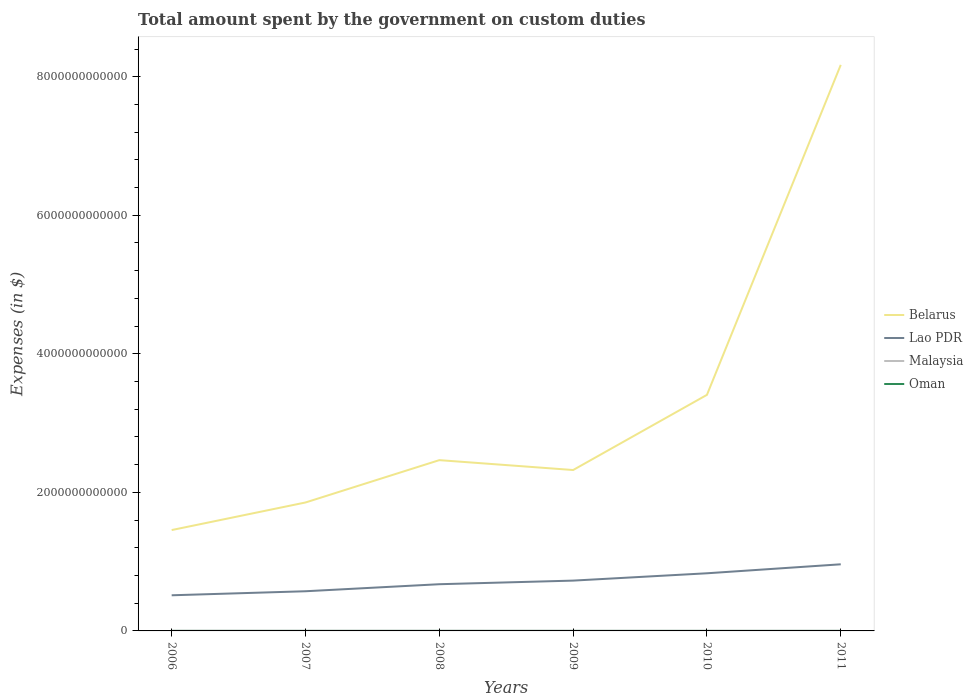How many different coloured lines are there?
Keep it short and to the point. 4. Is the number of lines equal to the number of legend labels?
Your response must be concise. Yes. Across all years, what is the maximum amount spent on custom duties by the government in Belarus?
Your answer should be very brief. 1.46e+12. In which year was the amount spent on custom duties by the government in Belarus maximum?
Make the answer very short. 2006. What is the total amount spent on custom duties by the government in Belarus in the graph?
Provide a succinct answer. -6.11e+11. What is the difference between the highest and the second highest amount spent on custom duties by the government in Malaysia?
Provide a short and direct response. 7.12e+08. Is the amount spent on custom duties by the government in Oman strictly greater than the amount spent on custom duties by the government in Belarus over the years?
Your response must be concise. Yes. How many lines are there?
Your answer should be compact. 4. What is the difference between two consecutive major ticks on the Y-axis?
Offer a very short reply. 2.00e+12. Are the values on the major ticks of Y-axis written in scientific E-notation?
Your response must be concise. No. Does the graph contain any zero values?
Offer a very short reply. No. Where does the legend appear in the graph?
Provide a succinct answer. Center right. What is the title of the graph?
Your response must be concise. Total amount spent by the government on custom duties. What is the label or title of the X-axis?
Your response must be concise. Years. What is the label or title of the Y-axis?
Keep it short and to the point. Expenses (in $). What is the Expenses (in $) in Belarus in 2006?
Give a very brief answer. 1.46e+12. What is the Expenses (in $) in Lao PDR in 2006?
Offer a terse response. 5.15e+11. What is the Expenses (in $) of Malaysia in 2006?
Provide a short and direct response. 2.68e+09. What is the Expenses (in $) of Oman in 2006?
Provide a succinct answer. 1.15e+08. What is the Expenses (in $) in Belarus in 2007?
Your answer should be compact. 1.85e+12. What is the Expenses (in $) of Lao PDR in 2007?
Offer a terse response. 5.73e+11. What is the Expenses (in $) of Malaysia in 2007?
Ensure brevity in your answer.  2.42e+09. What is the Expenses (in $) of Oman in 2007?
Your answer should be very brief. 1.60e+08. What is the Expenses (in $) of Belarus in 2008?
Provide a short and direct response. 2.47e+12. What is the Expenses (in $) in Lao PDR in 2008?
Give a very brief answer. 6.74e+11. What is the Expenses (in $) of Malaysia in 2008?
Your answer should be compact. 2.64e+09. What is the Expenses (in $) of Oman in 2008?
Make the answer very short. 2.27e+08. What is the Expenses (in $) of Belarus in 2009?
Provide a succinct answer. 2.32e+12. What is the Expenses (in $) in Lao PDR in 2009?
Your answer should be very brief. 7.26e+11. What is the Expenses (in $) in Malaysia in 2009?
Offer a terse response. 2.11e+09. What is the Expenses (in $) in Oman in 2009?
Ensure brevity in your answer.  1.58e+08. What is the Expenses (in $) of Belarus in 2010?
Offer a terse response. 3.41e+12. What is the Expenses (in $) in Lao PDR in 2010?
Provide a succinct answer. 8.32e+11. What is the Expenses (in $) of Malaysia in 2010?
Provide a short and direct response. 1.97e+09. What is the Expenses (in $) in Oman in 2010?
Keep it short and to the point. 1.80e+08. What is the Expenses (in $) of Belarus in 2011?
Your response must be concise. 8.17e+12. What is the Expenses (in $) in Lao PDR in 2011?
Make the answer very short. 9.62e+11. What is the Expenses (in $) in Malaysia in 2011?
Your answer should be very brief. 2.03e+09. What is the Expenses (in $) of Oman in 2011?
Offer a very short reply. 1.61e+08. Across all years, what is the maximum Expenses (in $) of Belarus?
Make the answer very short. 8.17e+12. Across all years, what is the maximum Expenses (in $) in Lao PDR?
Give a very brief answer. 9.62e+11. Across all years, what is the maximum Expenses (in $) of Malaysia?
Give a very brief answer. 2.68e+09. Across all years, what is the maximum Expenses (in $) of Oman?
Your answer should be compact. 2.27e+08. Across all years, what is the minimum Expenses (in $) of Belarus?
Offer a terse response. 1.46e+12. Across all years, what is the minimum Expenses (in $) in Lao PDR?
Keep it short and to the point. 5.15e+11. Across all years, what is the minimum Expenses (in $) in Malaysia?
Give a very brief answer. 1.97e+09. Across all years, what is the minimum Expenses (in $) of Oman?
Provide a succinct answer. 1.15e+08. What is the total Expenses (in $) in Belarus in the graph?
Your answer should be compact. 1.97e+13. What is the total Expenses (in $) of Lao PDR in the graph?
Your answer should be compact. 4.28e+12. What is the total Expenses (in $) of Malaysia in the graph?
Offer a very short reply. 1.38e+1. What is the total Expenses (in $) of Oman in the graph?
Keep it short and to the point. 1.00e+09. What is the difference between the Expenses (in $) in Belarus in 2006 and that in 2007?
Your answer should be compact. -3.98e+11. What is the difference between the Expenses (in $) in Lao PDR in 2006 and that in 2007?
Your response must be concise. -5.81e+1. What is the difference between the Expenses (in $) in Malaysia in 2006 and that in 2007?
Your answer should be very brief. 2.54e+08. What is the difference between the Expenses (in $) in Oman in 2006 and that in 2007?
Provide a succinct answer. -4.50e+07. What is the difference between the Expenses (in $) of Belarus in 2006 and that in 2008?
Offer a terse response. -1.01e+12. What is the difference between the Expenses (in $) of Lao PDR in 2006 and that in 2008?
Ensure brevity in your answer.  -1.60e+11. What is the difference between the Expenses (in $) in Malaysia in 2006 and that in 2008?
Your answer should be compact. 4.35e+07. What is the difference between the Expenses (in $) of Oman in 2006 and that in 2008?
Your answer should be very brief. -1.12e+08. What is the difference between the Expenses (in $) of Belarus in 2006 and that in 2009?
Your response must be concise. -8.67e+11. What is the difference between the Expenses (in $) in Lao PDR in 2006 and that in 2009?
Your answer should be very brief. -2.12e+11. What is the difference between the Expenses (in $) in Malaysia in 2006 and that in 2009?
Provide a short and direct response. 5.64e+08. What is the difference between the Expenses (in $) of Oman in 2006 and that in 2009?
Make the answer very short. -4.35e+07. What is the difference between the Expenses (in $) of Belarus in 2006 and that in 2010?
Keep it short and to the point. -1.95e+12. What is the difference between the Expenses (in $) in Lao PDR in 2006 and that in 2010?
Make the answer very short. -3.17e+11. What is the difference between the Expenses (in $) in Malaysia in 2006 and that in 2010?
Provide a short and direct response. 7.12e+08. What is the difference between the Expenses (in $) of Oman in 2006 and that in 2010?
Offer a terse response. -6.50e+07. What is the difference between the Expenses (in $) of Belarus in 2006 and that in 2011?
Offer a terse response. -6.72e+12. What is the difference between the Expenses (in $) in Lao PDR in 2006 and that in 2011?
Keep it short and to the point. -4.47e+11. What is the difference between the Expenses (in $) of Malaysia in 2006 and that in 2011?
Give a very brief answer. 6.53e+08. What is the difference between the Expenses (in $) in Oman in 2006 and that in 2011?
Keep it short and to the point. -4.66e+07. What is the difference between the Expenses (in $) of Belarus in 2007 and that in 2008?
Provide a short and direct response. -6.11e+11. What is the difference between the Expenses (in $) in Lao PDR in 2007 and that in 2008?
Your response must be concise. -1.02e+11. What is the difference between the Expenses (in $) in Malaysia in 2007 and that in 2008?
Offer a terse response. -2.11e+08. What is the difference between the Expenses (in $) in Oman in 2007 and that in 2008?
Your answer should be compact. -6.70e+07. What is the difference between the Expenses (in $) of Belarus in 2007 and that in 2009?
Ensure brevity in your answer.  -4.68e+11. What is the difference between the Expenses (in $) in Lao PDR in 2007 and that in 2009?
Provide a short and direct response. -1.54e+11. What is the difference between the Expenses (in $) in Malaysia in 2007 and that in 2009?
Give a very brief answer. 3.10e+08. What is the difference between the Expenses (in $) of Oman in 2007 and that in 2009?
Your answer should be very brief. 1.50e+06. What is the difference between the Expenses (in $) in Belarus in 2007 and that in 2010?
Keep it short and to the point. -1.55e+12. What is the difference between the Expenses (in $) in Lao PDR in 2007 and that in 2010?
Make the answer very short. -2.59e+11. What is the difference between the Expenses (in $) of Malaysia in 2007 and that in 2010?
Provide a short and direct response. 4.58e+08. What is the difference between the Expenses (in $) in Oman in 2007 and that in 2010?
Offer a terse response. -2.00e+07. What is the difference between the Expenses (in $) of Belarus in 2007 and that in 2011?
Keep it short and to the point. -6.32e+12. What is the difference between the Expenses (in $) of Lao PDR in 2007 and that in 2011?
Your answer should be compact. -3.89e+11. What is the difference between the Expenses (in $) in Malaysia in 2007 and that in 2011?
Provide a short and direct response. 3.98e+08. What is the difference between the Expenses (in $) in Oman in 2007 and that in 2011?
Provide a short and direct response. -1.60e+06. What is the difference between the Expenses (in $) in Belarus in 2008 and that in 2009?
Make the answer very short. 1.43e+11. What is the difference between the Expenses (in $) in Lao PDR in 2008 and that in 2009?
Your response must be concise. -5.20e+1. What is the difference between the Expenses (in $) of Malaysia in 2008 and that in 2009?
Make the answer very short. 5.21e+08. What is the difference between the Expenses (in $) of Oman in 2008 and that in 2009?
Your answer should be compact. 6.85e+07. What is the difference between the Expenses (in $) of Belarus in 2008 and that in 2010?
Offer a very short reply. -9.43e+11. What is the difference between the Expenses (in $) in Lao PDR in 2008 and that in 2010?
Your response must be concise. -1.58e+11. What is the difference between the Expenses (in $) of Malaysia in 2008 and that in 2010?
Your answer should be very brief. 6.69e+08. What is the difference between the Expenses (in $) in Oman in 2008 and that in 2010?
Your answer should be very brief. 4.70e+07. What is the difference between the Expenses (in $) of Belarus in 2008 and that in 2011?
Ensure brevity in your answer.  -5.71e+12. What is the difference between the Expenses (in $) in Lao PDR in 2008 and that in 2011?
Give a very brief answer. -2.88e+11. What is the difference between the Expenses (in $) in Malaysia in 2008 and that in 2011?
Ensure brevity in your answer.  6.09e+08. What is the difference between the Expenses (in $) of Oman in 2008 and that in 2011?
Make the answer very short. 6.54e+07. What is the difference between the Expenses (in $) of Belarus in 2009 and that in 2010?
Ensure brevity in your answer.  -1.09e+12. What is the difference between the Expenses (in $) in Lao PDR in 2009 and that in 2010?
Make the answer very short. -1.06e+11. What is the difference between the Expenses (in $) of Malaysia in 2009 and that in 2010?
Provide a short and direct response. 1.48e+08. What is the difference between the Expenses (in $) of Oman in 2009 and that in 2010?
Make the answer very short. -2.15e+07. What is the difference between the Expenses (in $) of Belarus in 2009 and that in 2011?
Provide a short and direct response. -5.85e+12. What is the difference between the Expenses (in $) in Lao PDR in 2009 and that in 2011?
Offer a terse response. -2.35e+11. What is the difference between the Expenses (in $) in Malaysia in 2009 and that in 2011?
Ensure brevity in your answer.  8.83e+07. What is the difference between the Expenses (in $) of Oman in 2009 and that in 2011?
Provide a succinct answer. -3.10e+06. What is the difference between the Expenses (in $) in Belarus in 2010 and that in 2011?
Provide a short and direct response. -4.76e+12. What is the difference between the Expenses (in $) of Lao PDR in 2010 and that in 2011?
Offer a terse response. -1.30e+11. What is the difference between the Expenses (in $) in Malaysia in 2010 and that in 2011?
Make the answer very short. -5.97e+07. What is the difference between the Expenses (in $) in Oman in 2010 and that in 2011?
Give a very brief answer. 1.84e+07. What is the difference between the Expenses (in $) in Belarus in 2006 and the Expenses (in $) in Lao PDR in 2007?
Your response must be concise. 8.83e+11. What is the difference between the Expenses (in $) in Belarus in 2006 and the Expenses (in $) in Malaysia in 2007?
Ensure brevity in your answer.  1.45e+12. What is the difference between the Expenses (in $) of Belarus in 2006 and the Expenses (in $) of Oman in 2007?
Your answer should be compact. 1.46e+12. What is the difference between the Expenses (in $) in Lao PDR in 2006 and the Expenses (in $) in Malaysia in 2007?
Your answer should be compact. 5.12e+11. What is the difference between the Expenses (in $) in Lao PDR in 2006 and the Expenses (in $) in Oman in 2007?
Offer a very short reply. 5.14e+11. What is the difference between the Expenses (in $) of Malaysia in 2006 and the Expenses (in $) of Oman in 2007?
Ensure brevity in your answer.  2.52e+09. What is the difference between the Expenses (in $) in Belarus in 2006 and the Expenses (in $) in Lao PDR in 2008?
Give a very brief answer. 7.82e+11. What is the difference between the Expenses (in $) in Belarus in 2006 and the Expenses (in $) in Malaysia in 2008?
Offer a very short reply. 1.45e+12. What is the difference between the Expenses (in $) of Belarus in 2006 and the Expenses (in $) of Oman in 2008?
Your answer should be very brief. 1.46e+12. What is the difference between the Expenses (in $) of Lao PDR in 2006 and the Expenses (in $) of Malaysia in 2008?
Make the answer very short. 5.12e+11. What is the difference between the Expenses (in $) in Lao PDR in 2006 and the Expenses (in $) in Oman in 2008?
Provide a succinct answer. 5.14e+11. What is the difference between the Expenses (in $) in Malaysia in 2006 and the Expenses (in $) in Oman in 2008?
Provide a succinct answer. 2.45e+09. What is the difference between the Expenses (in $) of Belarus in 2006 and the Expenses (in $) of Lao PDR in 2009?
Provide a succinct answer. 7.30e+11. What is the difference between the Expenses (in $) of Belarus in 2006 and the Expenses (in $) of Malaysia in 2009?
Offer a very short reply. 1.45e+12. What is the difference between the Expenses (in $) of Belarus in 2006 and the Expenses (in $) of Oman in 2009?
Keep it short and to the point. 1.46e+12. What is the difference between the Expenses (in $) in Lao PDR in 2006 and the Expenses (in $) in Malaysia in 2009?
Your answer should be very brief. 5.12e+11. What is the difference between the Expenses (in $) in Lao PDR in 2006 and the Expenses (in $) in Oman in 2009?
Keep it short and to the point. 5.14e+11. What is the difference between the Expenses (in $) of Malaysia in 2006 and the Expenses (in $) of Oman in 2009?
Provide a short and direct response. 2.52e+09. What is the difference between the Expenses (in $) in Belarus in 2006 and the Expenses (in $) in Lao PDR in 2010?
Provide a short and direct response. 6.24e+11. What is the difference between the Expenses (in $) of Belarus in 2006 and the Expenses (in $) of Malaysia in 2010?
Ensure brevity in your answer.  1.45e+12. What is the difference between the Expenses (in $) of Belarus in 2006 and the Expenses (in $) of Oman in 2010?
Offer a very short reply. 1.46e+12. What is the difference between the Expenses (in $) of Lao PDR in 2006 and the Expenses (in $) of Malaysia in 2010?
Your response must be concise. 5.13e+11. What is the difference between the Expenses (in $) of Lao PDR in 2006 and the Expenses (in $) of Oman in 2010?
Ensure brevity in your answer.  5.14e+11. What is the difference between the Expenses (in $) of Malaysia in 2006 and the Expenses (in $) of Oman in 2010?
Your answer should be very brief. 2.50e+09. What is the difference between the Expenses (in $) in Belarus in 2006 and the Expenses (in $) in Lao PDR in 2011?
Offer a very short reply. 4.94e+11. What is the difference between the Expenses (in $) in Belarus in 2006 and the Expenses (in $) in Malaysia in 2011?
Keep it short and to the point. 1.45e+12. What is the difference between the Expenses (in $) of Belarus in 2006 and the Expenses (in $) of Oman in 2011?
Your answer should be very brief. 1.46e+12. What is the difference between the Expenses (in $) of Lao PDR in 2006 and the Expenses (in $) of Malaysia in 2011?
Provide a short and direct response. 5.13e+11. What is the difference between the Expenses (in $) in Lao PDR in 2006 and the Expenses (in $) in Oman in 2011?
Your answer should be very brief. 5.14e+11. What is the difference between the Expenses (in $) of Malaysia in 2006 and the Expenses (in $) of Oman in 2011?
Make the answer very short. 2.52e+09. What is the difference between the Expenses (in $) in Belarus in 2007 and the Expenses (in $) in Lao PDR in 2008?
Provide a succinct answer. 1.18e+12. What is the difference between the Expenses (in $) in Belarus in 2007 and the Expenses (in $) in Malaysia in 2008?
Provide a short and direct response. 1.85e+12. What is the difference between the Expenses (in $) of Belarus in 2007 and the Expenses (in $) of Oman in 2008?
Keep it short and to the point. 1.85e+12. What is the difference between the Expenses (in $) of Lao PDR in 2007 and the Expenses (in $) of Malaysia in 2008?
Your answer should be compact. 5.70e+11. What is the difference between the Expenses (in $) of Lao PDR in 2007 and the Expenses (in $) of Oman in 2008?
Provide a short and direct response. 5.72e+11. What is the difference between the Expenses (in $) of Malaysia in 2007 and the Expenses (in $) of Oman in 2008?
Your answer should be compact. 2.20e+09. What is the difference between the Expenses (in $) of Belarus in 2007 and the Expenses (in $) of Lao PDR in 2009?
Offer a very short reply. 1.13e+12. What is the difference between the Expenses (in $) of Belarus in 2007 and the Expenses (in $) of Malaysia in 2009?
Offer a very short reply. 1.85e+12. What is the difference between the Expenses (in $) of Belarus in 2007 and the Expenses (in $) of Oman in 2009?
Your answer should be very brief. 1.85e+12. What is the difference between the Expenses (in $) in Lao PDR in 2007 and the Expenses (in $) in Malaysia in 2009?
Your answer should be very brief. 5.70e+11. What is the difference between the Expenses (in $) of Lao PDR in 2007 and the Expenses (in $) of Oman in 2009?
Offer a very short reply. 5.72e+11. What is the difference between the Expenses (in $) in Malaysia in 2007 and the Expenses (in $) in Oman in 2009?
Make the answer very short. 2.27e+09. What is the difference between the Expenses (in $) in Belarus in 2007 and the Expenses (in $) in Lao PDR in 2010?
Offer a very short reply. 1.02e+12. What is the difference between the Expenses (in $) of Belarus in 2007 and the Expenses (in $) of Malaysia in 2010?
Your answer should be very brief. 1.85e+12. What is the difference between the Expenses (in $) in Belarus in 2007 and the Expenses (in $) in Oman in 2010?
Ensure brevity in your answer.  1.85e+12. What is the difference between the Expenses (in $) in Lao PDR in 2007 and the Expenses (in $) in Malaysia in 2010?
Offer a very short reply. 5.71e+11. What is the difference between the Expenses (in $) of Lao PDR in 2007 and the Expenses (in $) of Oman in 2010?
Ensure brevity in your answer.  5.72e+11. What is the difference between the Expenses (in $) of Malaysia in 2007 and the Expenses (in $) of Oman in 2010?
Offer a very short reply. 2.24e+09. What is the difference between the Expenses (in $) in Belarus in 2007 and the Expenses (in $) in Lao PDR in 2011?
Offer a very short reply. 8.92e+11. What is the difference between the Expenses (in $) in Belarus in 2007 and the Expenses (in $) in Malaysia in 2011?
Ensure brevity in your answer.  1.85e+12. What is the difference between the Expenses (in $) of Belarus in 2007 and the Expenses (in $) of Oman in 2011?
Provide a succinct answer. 1.85e+12. What is the difference between the Expenses (in $) of Lao PDR in 2007 and the Expenses (in $) of Malaysia in 2011?
Your response must be concise. 5.71e+11. What is the difference between the Expenses (in $) of Lao PDR in 2007 and the Expenses (in $) of Oman in 2011?
Your answer should be very brief. 5.72e+11. What is the difference between the Expenses (in $) in Malaysia in 2007 and the Expenses (in $) in Oman in 2011?
Your response must be concise. 2.26e+09. What is the difference between the Expenses (in $) of Belarus in 2008 and the Expenses (in $) of Lao PDR in 2009?
Your answer should be very brief. 1.74e+12. What is the difference between the Expenses (in $) in Belarus in 2008 and the Expenses (in $) in Malaysia in 2009?
Your response must be concise. 2.46e+12. What is the difference between the Expenses (in $) in Belarus in 2008 and the Expenses (in $) in Oman in 2009?
Offer a terse response. 2.47e+12. What is the difference between the Expenses (in $) of Lao PDR in 2008 and the Expenses (in $) of Malaysia in 2009?
Give a very brief answer. 6.72e+11. What is the difference between the Expenses (in $) of Lao PDR in 2008 and the Expenses (in $) of Oman in 2009?
Provide a short and direct response. 6.74e+11. What is the difference between the Expenses (in $) of Malaysia in 2008 and the Expenses (in $) of Oman in 2009?
Ensure brevity in your answer.  2.48e+09. What is the difference between the Expenses (in $) in Belarus in 2008 and the Expenses (in $) in Lao PDR in 2010?
Give a very brief answer. 1.63e+12. What is the difference between the Expenses (in $) in Belarus in 2008 and the Expenses (in $) in Malaysia in 2010?
Make the answer very short. 2.46e+12. What is the difference between the Expenses (in $) in Belarus in 2008 and the Expenses (in $) in Oman in 2010?
Your answer should be very brief. 2.47e+12. What is the difference between the Expenses (in $) in Lao PDR in 2008 and the Expenses (in $) in Malaysia in 2010?
Your response must be concise. 6.72e+11. What is the difference between the Expenses (in $) of Lao PDR in 2008 and the Expenses (in $) of Oman in 2010?
Ensure brevity in your answer.  6.74e+11. What is the difference between the Expenses (in $) in Malaysia in 2008 and the Expenses (in $) in Oman in 2010?
Make the answer very short. 2.46e+09. What is the difference between the Expenses (in $) in Belarus in 2008 and the Expenses (in $) in Lao PDR in 2011?
Your answer should be compact. 1.50e+12. What is the difference between the Expenses (in $) in Belarus in 2008 and the Expenses (in $) in Malaysia in 2011?
Your answer should be compact. 2.46e+12. What is the difference between the Expenses (in $) in Belarus in 2008 and the Expenses (in $) in Oman in 2011?
Give a very brief answer. 2.47e+12. What is the difference between the Expenses (in $) in Lao PDR in 2008 and the Expenses (in $) in Malaysia in 2011?
Offer a terse response. 6.72e+11. What is the difference between the Expenses (in $) in Lao PDR in 2008 and the Expenses (in $) in Oman in 2011?
Keep it short and to the point. 6.74e+11. What is the difference between the Expenses (in $) of Malaysia in 2008 and the Expenses (in $) of Oman in 2011?
Make the answer very short. 2.47e+09. What is the difference between the Expenses (in $) of Belarus in 2009 and the Expenses (in $) of Lao PDR in 2010?
Give a very brief answer. 1.49e+12. What is the difference between the Expenses (in $) of Belarus in 2009 and the Expenses (in $) of Malaysia in 2010?
Provide a short and direct response. 2.32e+12. What is the difference between the Expenses (in $) in Belarus in 2009 and the Expenses (in $) in Oman in 2010?
Provide a short and direct response. 2.32e+12. What is the difference between the Expenses (in $) in Lao PDR in 2009 and the Expenses (in $) in Malaysia in 2010?
Offer a very short reply. 7.24e+11. What is the difference between the Expenses (in $) of Lao PDR in 2009 and the Expenses (in $) of Oman in 2010?
Provide a succinct answer. 7.26e+11. What is the difference between the Expenses (in $) of Malaysia in 2009 and the Expenses (in $) of Oman in 2010?
Offer a very short reply. 1.93e+09. What is the difference between the Expenses (in $) in Belarus in 2009 and the Expenses (in $) in Lao PDR in 2011?
Your response must be concise. 1.36e+12. What is the difference between the Expenses (in $) in Belarus in 2009 and the Expenses (in $) in Malaysia in 2011?
Your answer should be compact. 2.32e+12. What is the difference between the Expenses (in $) of Belarus in 2009 and the Expenses (in $) of Oman in 2011?
Offer a terse response. 2.32e+12. What is the difference between the Expenses (in $) in Lao PDR in 2009 and the Expenses (in $) in Malaysia in 2011?
Offer a very short reply. 7.24e+11. What is the difference between the Expenses (in $) of Lao PDR in 2009 and the Expenses (in $) of Oman in 2011?
Provide a short and direct response. 7.26e+11. What is the difference between the Expenses (in $) in Malaysia in 2009 and the Expenses (in $) in Oman in 2011?
Provide a short and direct response. 1.95e+09. What is the difference between the Expenses (in $) in Belarus in 2010 and the Expenses (in $) in Lao PDR in 2011?
Your answer should be compact. 2.45e+12. What is the difference between the Expenses (in $) of Belarus in 2010 and the Expenses (in $) of Malaysia in 2011?
Provide a succinct answer. 3.41e+12. What is the difference between the Expenses (in $) of Belarus in 2010 and the Expenses (in $) of Oman in 2011?
Provide a succinct answer. 3.41e+12. What is the difference between the Expenses (in $) in Lao PDR in 2010 and the Expenses (in $) in Malaysia in 2011?
Ensure brevity in your answer.  8.30e+11. What is the difference between the Expenses (in $) in Lao PDR in 2010 and the Expenses (in $) in Oman in 2011?
Provide a succinct answer. 8.32e+11. What is the difference between the Expenses (in $) in Malaysia in 2010 and the Expenses (in $) in Oman in 2011?
Give a very brief answer. 1.81e+09. What is the average Expenses (in $) in Belarus per year?
Give a very brief answer. 3.28e+12. What is the average Expenses (in $) of Lao PDR per year?
Ensure brevity in your answer.  7.14e+11. What is the average Expenses (in $) of Malaysia per year?
Keep it short and to the point. 2.31e+09. What is the average Expenses (in $) of Oman per year?
Your answer should be compact. 1.67e+08. In the year 2006, what is the difference between the Expenses (in $) in Belarus and Expenses (in $) in Lao PDR?
Make the answer very short. 9.41e+11. In the year 2006, what is the difference between the Expenses (in $) in Belarus and Expenses (in $) in Malaysia?
Offer a very short reply. 1.45e+12. In the year 2006, what is the difference between the Expenses (in $) of Belarus and Expenses (in $) of Oman?
Provide a succinct answer. 1.46e+12. In the year 2006, what is the difference between the Expenses (in $) of Lao PDR and Expenses (in $) of Malaysia?
Make the answer very short. 5.12e+11. In the year 2006, what is the difference between the Expenses (in $) of Lao PDR and Expenses (in $) of Oman?
Your answer should be very brief. 5.14e+11. In the year 2006, what is the difference between the Expenses (in $) in Malaysia and Expenses (in $) in Oman?
Provide a succinct answer. 2.56e+09. In the year 2007, what is the difference between the Expenses (in $) in Belarus and Expenses (in $) in Lao PDR?
Make the answer very short. 1.28e+12. In the year 2007, what is the difference between the Expenses (in $) of Belarus and Expenses (in $) of Malaysia?
Provide a short and direct response. 1.85e+12. In the year 2007, what is the difference between the Expenses (in $) of Belarus and Expenses (in $) of Oman?
Keep it short and to the point. 1.85e+12. In the year 2007, what is the difference between the Expenses (in $) in Lao PDR and Expenses (in $) in Malaysia?
Make the answer very short. 5.70e+11. In the year 2007, what is the difference between the Expenses (in $) in Lao PDR and Expenses (in $) in Oman?
Provide a succinct answer. 5.72e+11. In the year 2007, what is the difference between the Expenses (in $) of Malaysia and Expenses (in $) of Oman?
Your answer should be very brief. 2.26e+09. In the year 2008, what is the difference between the Expenses (in $) of Belarus and Expenses (in $) of Lao PDR?
Ensure brevity in your answer.  1.79e+12. In the year 2008, what is the difference between the Expenses (in $) of Belarus and Expenses (in $) of Malaysia?
Provide a succinct answer. 2.46e+12. In the year 2008, what is the difference between the Expenses (in $) in Belarus and Expenses (in $) in Oman?
Offer a terse response. 2.46e+12. In the year 2008, what is the difference between the Expenses (in $) of Lao PDR and Expenses (in $) of Malaysia?
Your answer should be compact. 6.72e+11. In the year 2008, what is the difference between the Expenses (in $) in Lao PDR and Expenses (in $) in Oman?
Your response must be concise. 6.74e+11. In the year 2008, what is the difference between the Expenses (in $) of Malaysia and Expenses (in $) of Oman?
Your response must be concise. 2.41e+09. In the year 2009, what is the difference between the Expenses (in $) in Belarus and Expenses (in $) in Lao PDR?
Ensure brevity in your answer.  1.60e+12. In the year 2009, what is the difference between the Expenses (in $) of Belarus and Expenses (in $) of Malaysia?
Keep it short and to the point. 2.32e+12. In the year 2009, what is the difference between the Expenses (in $) in Belarus and Expenses (in $) in Oman?
Give a very brief answer. 2.32e+12. In the year 2009, what is the difference between the Expenses (in $) in Lao PDR and Expenses (in $) in Malaysia?
Offer a terse response. 7.24e+11. In the year 2009, what is the difference between the Expenses (in $) of Lao PDR and Expenses (in $) of Oman?
Your answer should be compact. 7.26e+11. In the year 2009, what is the difference between the Expenses (in $) of Malaysia and Expenses (in $) of Oman?
Ensure brevity in your answer.  1.96e+09. In the year 2010, what is the difference between the Expenses (in $) in Belarus and Expenses (in $) in Lao PDR?
Provide a succinct answer. 2.58e+12. In the year 2010, what is the difference between the Expenses (in $) in Belarus and Expenses (in $) in Malaysia?
Provide a short and direct response. 3.41e+12. In the year 2010, what is the difference between the Expenses (in $) of Belarus and Expenses (in $) of Oman?
Keep it short and to the point. 3.41e+12. In the year 2010, what is the difference between the Expenses (in $) of Lao PDR and Expenses (in $) of Malaysia?
Ensure brevity in your answer.  8.30e+11. In the year 2010, what is the difference between the Expenses (in $) in Lao PDR and Expenses (in $) in Oman?
Offer a very short reply. 8.32e+11. In the year 2010, what is the difference between the Expenses (in $) in Malaysia and Expenses (in $) in Oman?
Your answer should be very brief. 1.79e+09. In the year 2011, what is the difference between the Expenses (in $) in Belarus and Expenses (in $) in Lao PDR?
Offer a terse response. 7.21e+12. In the year 2011, what is the difference between the Expenses (in $) in Belarus and Expenses (in $) in Malaysia?
Provide a short and direct response. 8.17e+12. In the year 2011, what is the difference between the Expenses (in $) in Belarus and Expenses (in $) in Oman?
Your answer should be compact. 8.17e+12. In the year 2011, what is the difference between the Expenses (in $) in Lao PDR and Expenses (in $) in Malaysia?
Provide a short and direct response. 9.60e+11. In the year 2011, what is the difference between the Expenses (in $) of Lao PDR and Expenses (in $) of Oman?
Your response must be concise. 9.62e+11. In the year 2011, what is the difference between the Expenses (in $) in Malaysia and Expenses (in $) in Oman?
Provide a short and direct response. 1.86e+09. What is the ratio of the Expenses (in $) in Belarus in 2006 to that in 2007?
Your answer should be very brief. 0.79. What is the ratio of the Expenses (in $) of Lao PDR in 2006 to that in 2007?
Give a very brief answer. 0.9. What is the ratio of the Expenses (in $) of Malaysia in 2006 to that in 2007?
Make the answer very short. 1.1. What is the ratio of the Expenses (in $) of Oman in 2006 to that in 2007?
Give a very brief answer. 0.72. What is the ratio of the Expenses (in $) in Belarus in 2006 to that in 2008?
Offer a terse response. 0.59. What is the ratio of the Expenses (in $) in Lao PDR in 2006 to that in 2008?
Offer a very short reply. 0.76. What is the ratio of the Expenses (in $) in Malaysia in 2006 to that in 2008?
Ensure brevity in your answer.  1.02. What is the ratio of the Expenses (in $) in Oman in 2006 to that in 2008?
Provide a succinct answer. 0.51. What is the ratio of the Expenses (in $) in Belarus in 2006 to that in 2009?
Your response must be concise. 0.63. What is the ratio of the Expenses (in $) in Lao PDR in 2006 to that in 2009?
Your answer should be compact. 0.71. What is the ratio of the Expenses (in $) in Malaysia in 2006 to that in 2009?
Ensure brevity in your answer.  1.27. What is the ratio of the Expenses (in $) in Oman in 2006 to that in 2009?
Offer a very short reply. 0.72. What is the ratio of the Expenses (in $) of Belarus in 2006 to that in 2010?
Provide a succinct answer. 0.43. What is the ratio of the Expenses (in $) in Lao PDR in 2006 to that in 2010?
Provide a short and direct response. 0.62. What is the ratio of the Expenses (in $) of Malaysia in 2006 to that in 2010?
Give a very brief answer. 1.36. What is the ratio of the Expenses (in $) of Oman in 2006 to that in 2010?
Make the answer very short. 0.64. What is the ratio of the Expenses (in $) of Belarus in 2006 to that in 2011?
Give a very brief answer. 0.18. What is the ratio of the Expenses (in $) in Lao PDR in 2006 to that in 2011?
Your response must be concise. 0.54. What is the ratio of the Expenses (in $) in Malaysia in 2006 to that in 2011?
Offer a terse response. 1.32. What is the ratio of the Expenses (in $) in Oman in 2006 to that in 2011?
Provide a short and direct response. 0.71. What is the ratio of the Expenses (in $) of Belarus in 2007 to that in 2008?
Provide a short and direct response. 0.75. What is the ratio of the Expenses (in $) in Lao PDR in 2007 to that in 2008?
Make the answer very short. 0.85. What is the ratio of the Expenses (in $) of Malaysia in 2007 to that in 2008?
Your response must be concise. 0.92. What is the ratio of the Expenses (in $) of Oman in 2007 to that in 2008?
Offer a very short reply. 0.7. What is the ratio of the Expenses (in $) of Belarus in 2007 to that in 2009?
Offer a terse response. 0.8. What is the ratio of the Expenses (in $) in Lao PDR in 2007 to that in 2009?
Provide a succinct answer. 0.79. What is the ratio of the Expenses (in $) of Malaysia in 2007 to that in 2009?
Provide a succinct answer. 1.15. What is the ratio of the Expenses (in $) in Oman in 2007 to that in 2009?
Provide a succinct answer. 1.01. What is the ratio of the Expenses (in $) in Belarus in 2007 to that in 2010?
Give a very brief answer. 0.54. What is the ratio of the Expenses (in $) of Lao PDR in 2007 to that in 2010?
Your answer should be compact. 0.69. What is the ratio of the Expenses (in $) in Malaysia in 2007 to that in 2010?
Offer a very short reply. 1.23. What is the ratio of the Expenses (in $) in Oman in 2007 to that in 2010?
Provide a succinct answer. 0.89. What is the ratio of the Expenses (in $) in Belarus in 2007 to that in 2011?
Give a very brief answer. 0.23. What is the ratio of the Expenses (in $) in Lao PDR in 2007 to that in 2011?
Keep it short and to the point. 0.6. What is the ratio of the Expenses (in $) in Malaysia in 2007 to that in 2011?
Your response must be concise. 1.2. What is the ratio of the Expenses (in $) in Belarus in 2008 to that in 2009?
Make the answer very short. 1.06. What is the ratio of the Expenses (in $) of Lao PDR in 2008 to that in 2009?
Provide a succinct answer. 0.93. What is the ratio of the Expenses (in $) in Malaysia in 2008 to that in 2009?
Keep it short and to the point. 1.25. What is the ratio of the Expenses (in $) in Oman in 2008 to that in 2009?
Make the answer very short. 1.43. What is the ratio of the Expenses (in $) of Belarus in 2008 to that in 2010?
Give a very brief answer. 0.72. What is the ratio of the Expenses (in $) in Lao PDR in 2008 to that in 2010?
Offer a terse response. 0.81. What is the ratio of the Expenses (in $) in Malaysia in 2008 to that in 2010?
Make the answer very short. 1.34. What is the ratio of the Expenses (in $) in Oman in 2008 to that in 2010?
Give a very brief answer. 1.26. What is the ratio of the Expenses (in $) of Belarus in 2008 to that in 2011?
Offer a terse response. 0.3. What is the ratio of the Expenses (in $) of Lao PDR in 2008 to that in 2011?
Keep it short and to the point. 0.7. What is the ratio of the Expenses (in $) in Malaysia in 2008 to that in 2011?
Offer a terse response. 1.3. What is the ratio of the Expenses (in $) in Oman in 2008 to that in 2011?
Ensure brevity in your answer.  1.41. What is the ratio of the Expenses (in $) of Belarus in 2009 to that in 2010?
Keep it short and to the point. 0.68. What is the ratio of the Expenses (in $) of Lao PDR in 2009 to that in 2010?
Keep it short and to the point. 0.87. What is the ratio of the Expenses (in $) in Malaysia in 2009 to that in 2010?
Your response must be concise. 1.08. What is the ratio of the Expenses (in $) of Oman in 2009 to that in 2010?
Keep it short and to the point. 0.88. What is the ratio of the Expenses (in $) in Belarus in 2009 to that in 2011?
Offer a very short reply. 0.28. What is the ratio of the Expenses (in $) in Lao PDR in 2009 to that in 2011?
Your answer should be very brief. 0.76. What is the ratio of the Expenses (in $) of Malaysia in 2009 to that in 2011?
Provide a short and direct response. 1.04. What is the ratio of the Expenses (in $) in Oman in 2009 to that in 2011?
Provide a short and direct response. 0.98. What is the ratio of the Expenses (in $) of Belarus in 2010 to that in 2011?
Make the answer very short. 0.42. What is the ratio of the Expenses (in $) of Lao PDR in 2010 to that in 2011?
Offer a terse response. 0.87. What is the ratio of the Expenses (in $) in Malaysia in 2010 to that in 2011?
Offer a terse response. 0.97. What is the ratio of the Expenses (in $) of Oman in 2010 to that in 2011?
Your answer should be compact. 1.11. What is the difference between the highest and the second highest Expenses (in $) of Belarus?
Keep it short and to the point. 4.76e+12. What is the difference between the highest and the second highest Expenses (in $) in Lao PDR?
Your answer should be very brief. 1.30e+11. What is the difference between the highest and the second highest Expenses (in $) in Malaysia?
Provide a short and direct response. 4.35e+07. What is the difference between the highest and the second highest Expenses (in $) in Oman?
Ensure brevity in your answer.  4.70e+07. What is the difference between the highest and the lowest Expenses (in $) in Belarus?
Ensure brevity in your answer.  6.72e+12. What is the difference between the highest and the lowest Expenses (in $) in Lao PDR?
Provide a short and direct response. 4.47e+11. What is the difference between the highest and the lowest Expenses (in $) of Malaysia?
Your response must be concise. 7.12e+08. What is the difference between the highest and the lowest Expenses (in $) of Oman?
Your response must be concise. 1.12e+08. 